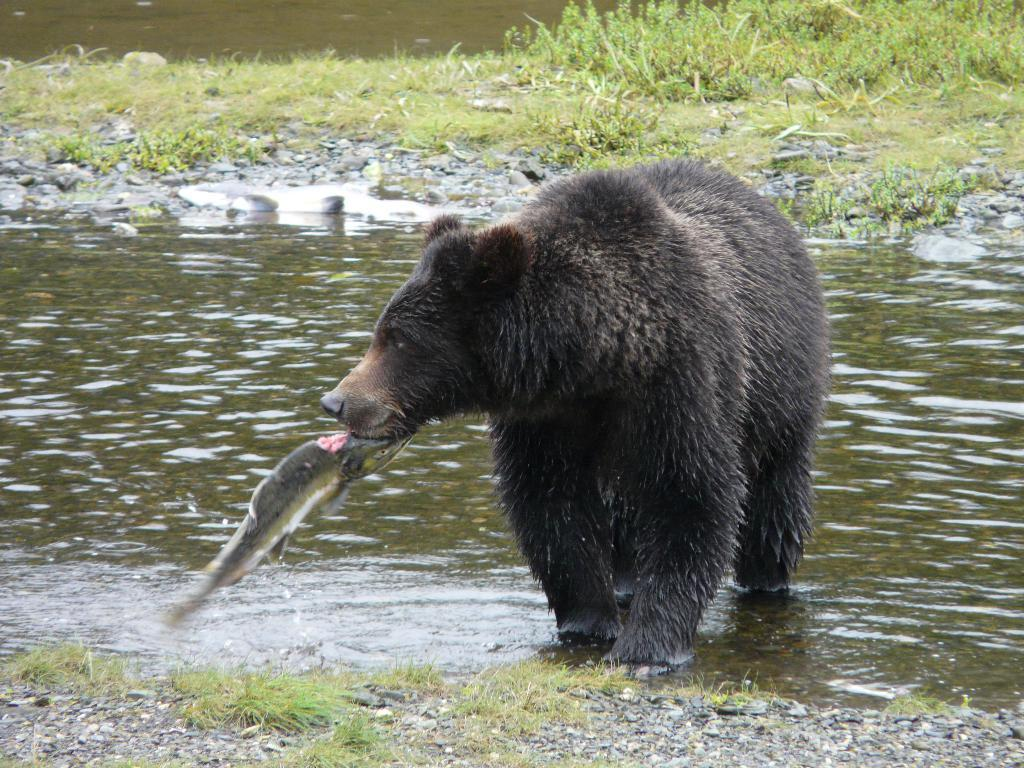What animal is present in the image? There is a bear in the image. What is the bear holding in the image? The bear is holding a fish in the image. Where are the bear and fish located? The bear and fish are in the water in the image. What other objects or elements can be seen in the image? There are stones and plants in the image. What type of volleyball game is being played in the image? There is no volleyball game present in the image. Can you describe the woman's attire in the image? There is no woman present in the image. 